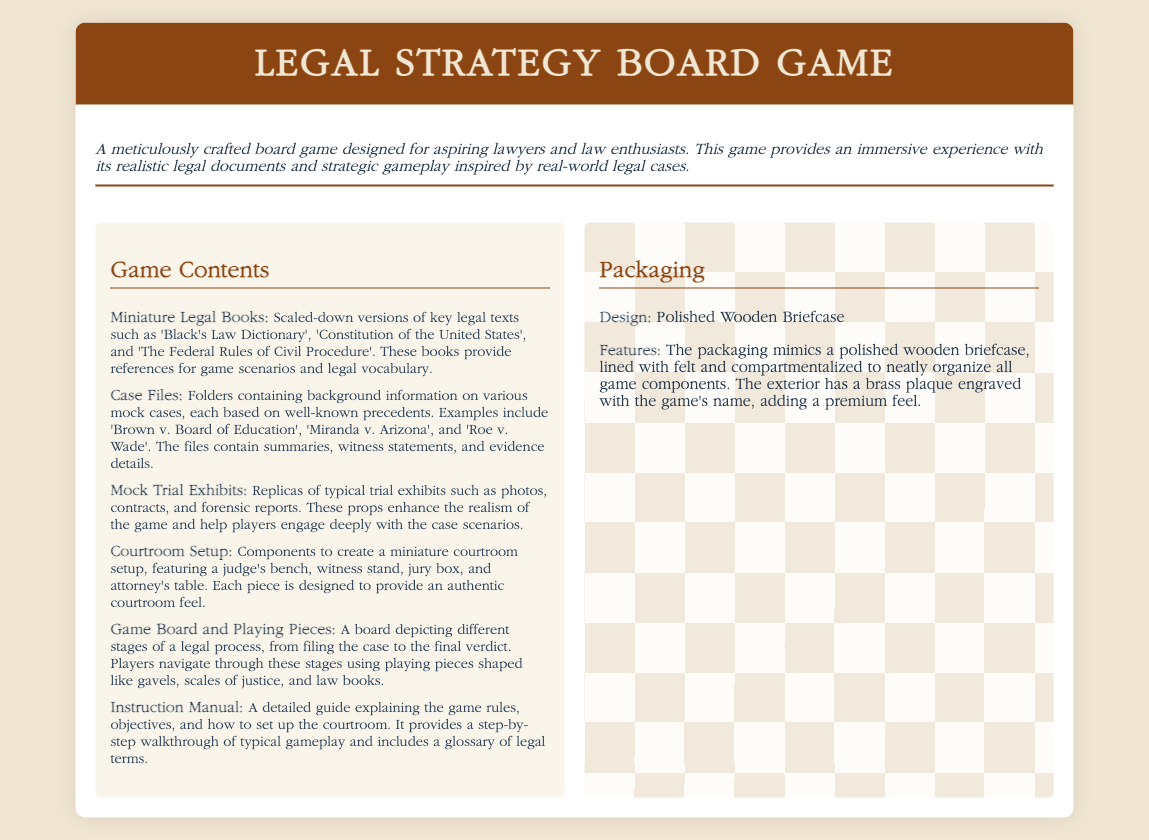What is the design of the packaging? The design of the packaging is described in the document as mimicking a polished wooden briefcase.
Answer: Polished Wooden Briefcase What type of instruction does the manual provide? The instruction manual provides a detailed guide explaining the game rules, objectives, and how to set up the courtroom.
Answer: Detailed guide How many miniature legal books are included? The exact number of miniature legal books isn't specified, but they represent key legal texts.
Answer: Multiple Which famous case is included in the case files? The case files contain background information on various mock cases, including 'Brown v. Board of Education'.
Answer: Brown v. Board of Education What items are used as playing pieces? Playing pieces are shaped like gavels, scales of justice, and law books.
Answer: Gavel, scales of justice, law books What is included in the courtroom setup? The courtroom setup includes a judge's bench, witness stand, jury box, and attorney's table.
Answer: Judge's bench, witness stand, jury box, attorney's table What color is used for the header background? The header background is mentioned as having a brown color.
Answer: Brown What does the packaging feature in terms of organization? The packaging is compartmentalized to neatly organize all game components.
Answer: Compartmentalized 